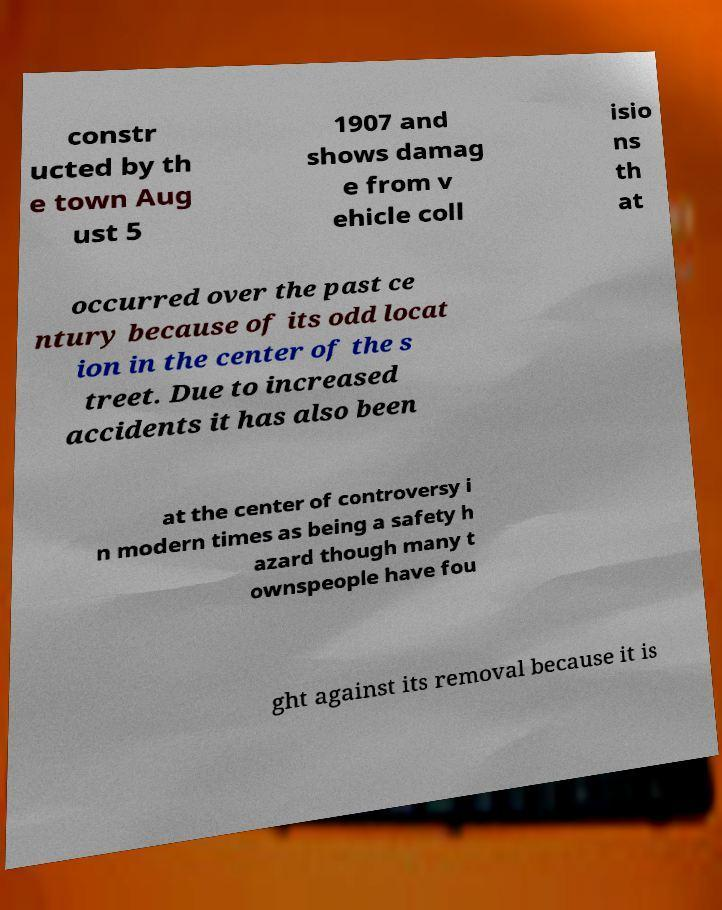Can you read and provide the text displayed in the image?This photo seems to have some interesting text. Can you extract and type it out for me? constr ucted by th e town Aug ust 5 1907 and shows damag e from v ehicle coll isio ns th at occurred over the past ce ntury because of its odd locat ion in the center of the s treet. Due to increased accidents it has also been at the center of controversy i n modern times as being a safety h azard though many t ownspeople have fou ght against its removal because it is 